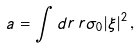<formula> <loc_0><loc_0><loc_500><loc_500>a = \int d r \, r \sigma _ { 0 } | \xi | ^ { 2 } \, ,</formula> 